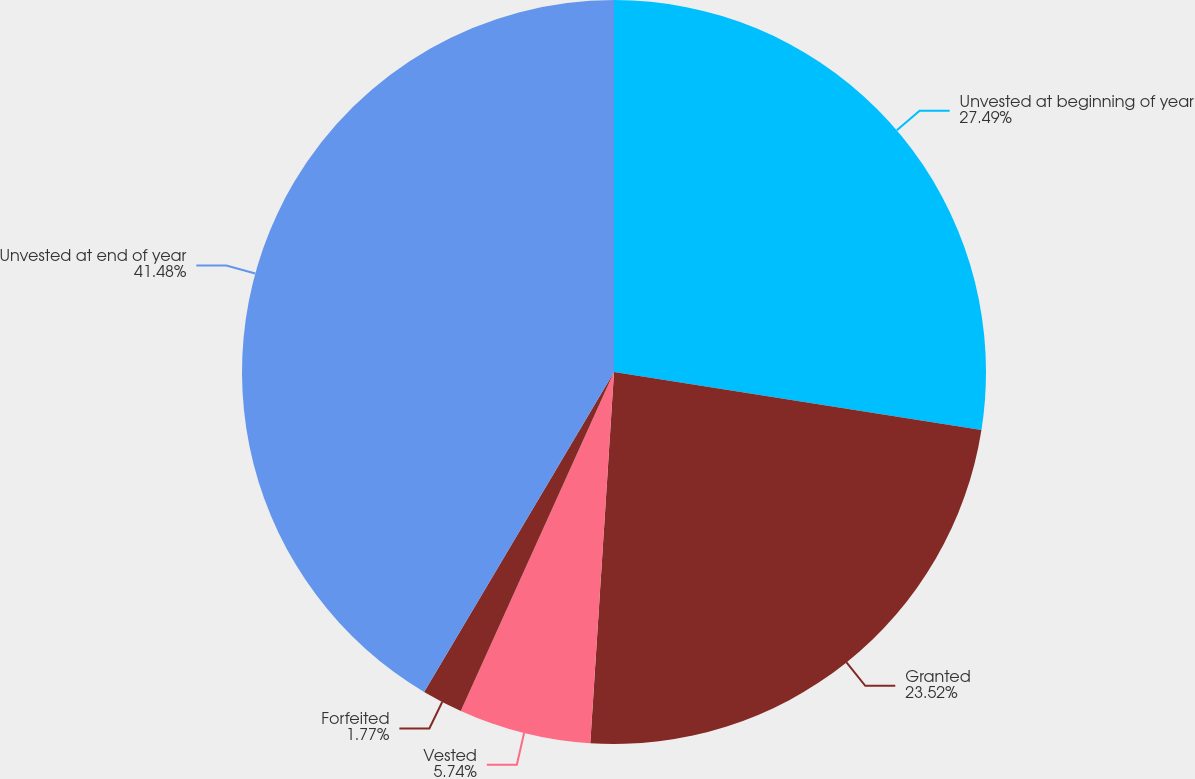<chart> <loc_0><loc_0><loc_500><loc_500><pie_chart><fcel>Unvested at beginning of year<fcel>Granted<fcel>Vested<fcel>Forfeited<fcel>Unvested at end of year<nl><fcel>27.49%<fcel>23.52%<fcel>5.74%<fcel>1.77%<fcel>41.47%<nl></chart> 